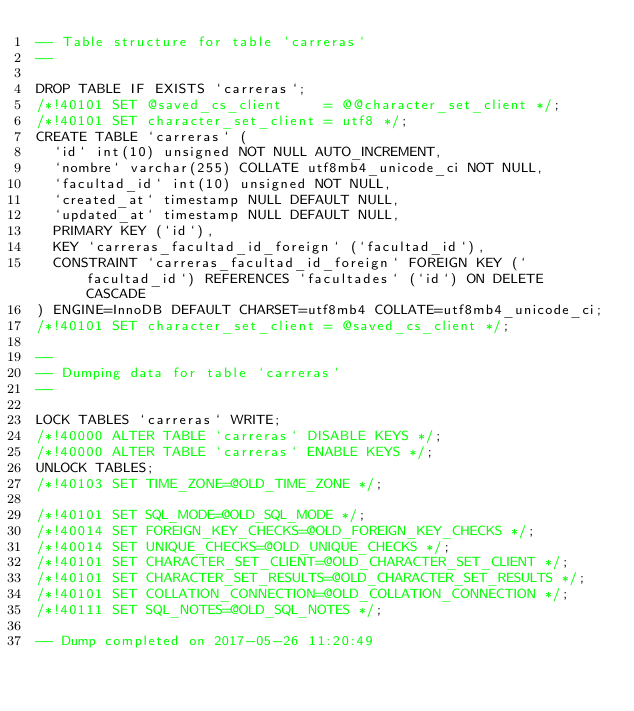<code> <loc_0><loc_0><loc_500><loc_500><_SQL_>-- Table structure for table `carreras`
--

DROP TABLE IF EXISTS `carreras`;
/*!40101 SET @saved_cs_client     = @@character_set_client */;
/*!40101 SET character_set_client = utf8 */;
CREATE TABLE `carreras` (
  `id` int(10) unsigned NOT NULL AUTO_INCREMENT,
  `nombre` varchar(255) COLLATE utf8mb4_unicode_ci NOT NULL,
  `facultad_id` int(10) unsigned NOT NULL,
  `created_at` timestamp NULL DEFAULT NULL,
  `updated_at` timestamp NULL DEFAULT NULL,
  PRIMARY KEY (`id`),
  KEY `carreras_facultad_id_foreign` (`facultad_id`),
  CONSTRAINT `carreras_facultad_id_foreign` FOREIGN KEY (`facultad_id`) REFERENCES `facultades` (`id`) ON DELETE CASCADE
) ENGINE=InnoDB DEFAULT CHARSET=utf8mb4 COLLATE=utf8mb4_unicode_ci;
/*!40101 SET character_set_client = @saved_cs_client */;

--
-- Dumping data for table `carreras`
--

LOCK TABLES `carreras` WRITE;
/*!40000 ALTER TABLE `carreras` DISABLE KEYS */;
/*!40000 ALTER TABLE `carreras` ENABLE KEYS */;
UNLOCK TABLES;
/*!40103 SET TIME_ZONE=@OLD_TIME_ZONE */;

/*!40101 SET SQL_MODE=@OLD_SQL_MODE */;
/*!40014 SET FOREIGN_KEY_CHECKS=@OLD_FOREIGN_KEY_CHECKS */;
/*!40014 SET UNIQUE_CHECKS=@OLD_UNIQUE_CHECKS */;
/*!40101 SET CHARACTER_SET_CLIENT=@OLD_CHARACTER_SET_CLIENT */;
/*!40101 SET CHARACTER_SET_RESULTS=@OLD_CHARACTER_SET_RESULTS */;
/*!40101 SET COLLATION_CONNECTION=@OLD_COLLATION_CONNECTION */;
/*!40111 SET SQL_NOTES=@OLD_SQL_NOTES */;

-- Dump completed on 2017-05-26 11:20:49
</code> 